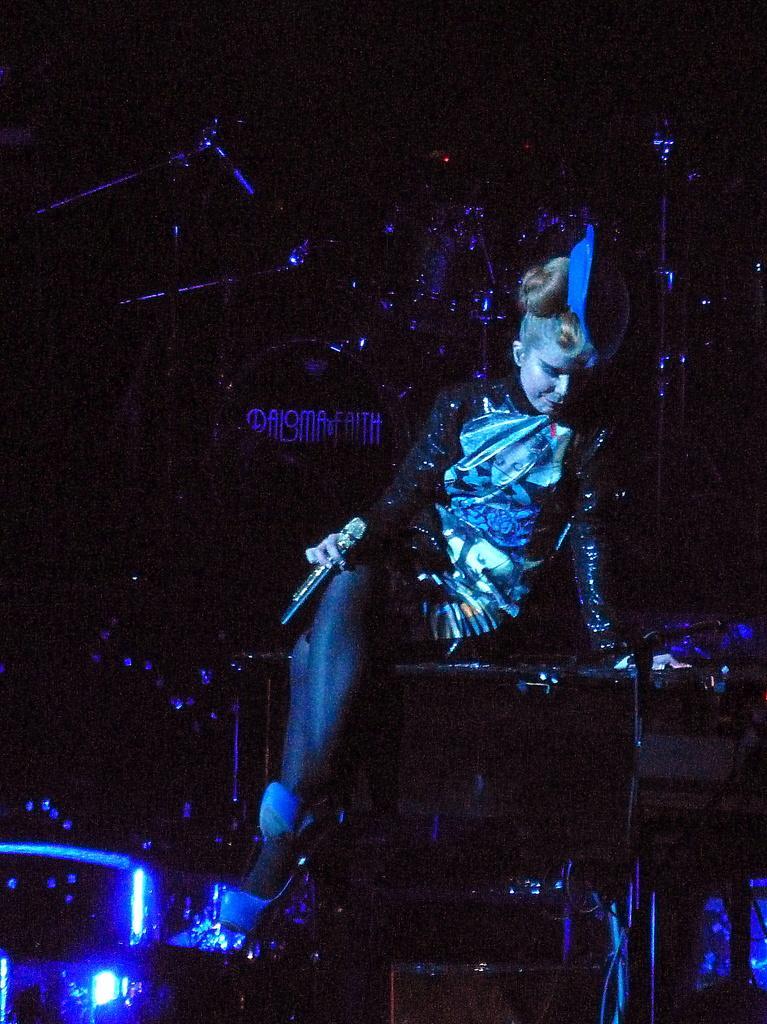Please provide a concise description of this image. In this image we can see a lady person holding microphone sitting on something and we can see drums, some musical instruments. 